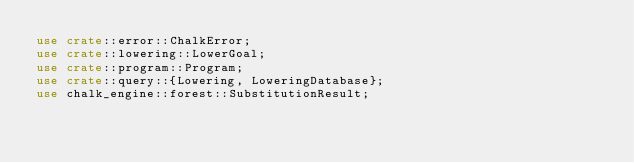<code> <loc_0><loc_0><loc_500><loc_500><_Rust_>use crate::error::ChalkError;
use crate::lowering::LowerGoal;
use crate::program::Program;
use crate::query::{Lowering, LoweringDatabase};
use chalk_engine::forest::SubstitutionResult;</code> 